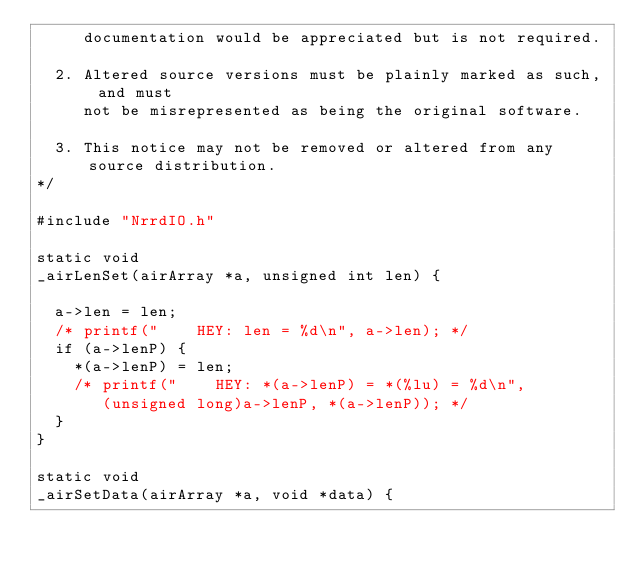<code> <loc_0><loc_0><loc_500><loc_500><_C_>     documentation would be appreciated but is not required.

  2. Altered source versions must be plainly marked as such, and must
     not be misrepresented as being the original software.

  3. This notice may not be removed or altered from any source distribution.
*/

#include "NrrdIO.h"

static void
_airLenSet(airArray *a, unsigned int len) {

  a->len = len;
  /* printf("    HEY: len = %d\n", a->len); */
  if (a->lenP) {
    *(a->lenP) = len;
    /* printf("    HEY: *(a->lenP) = *(%lu) = %d\n",
       (unsigned long)a->lenP, *(a->lenP)); */
  }
}

static void
_airSetData(airArray *a, void *data) {
</code> 